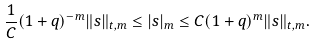<formula> <loc_0><loc_0><loc_500><loc_500>& \frac { 1 } { C } ( 1 + q ) ^ { - m } \| s \| _ { t , m } \leq | s | _ { m } \leq C ( 1 + q ) ^ { m } \| s \| _ { t , m } .</formula> 